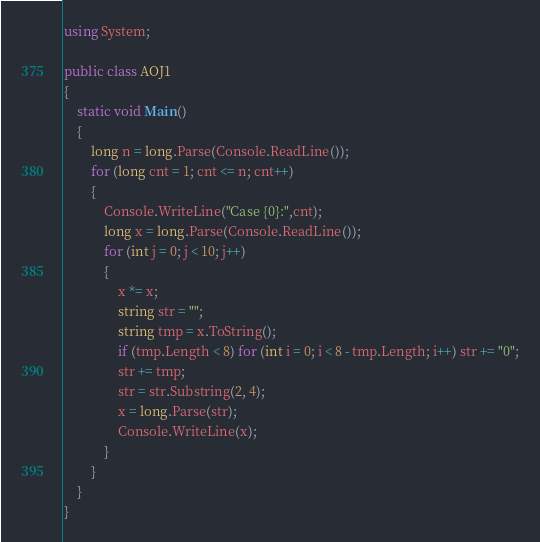<code> <loc_0><loc_0><loc_500><loc_500><_C#_>using System;

public class AOJ1
{
    static void Main()
    {
        long n = long.Parse(Console.ReadLine());
        for (long cnt = 1; cnt <= n; cnt++)
        {
            Console.WriteLine("Case {0}:",cnt);
            long x = long.Parse(Console.ReadLine());
            for (int j = 0; j < 10; j++)
            {
                x *= x;
                string str = "";
                string tmp = x.ToString();
                if (tmp.Length < 8) for (int i = 0; i < 8 - tmp.Length; i++) str += "0";
                str += tmp;
                str = str.Substring(2, 4);
                x = long.Parse(str);
                Console.WriteLine(x);
            }
        }
    }
}</code> 